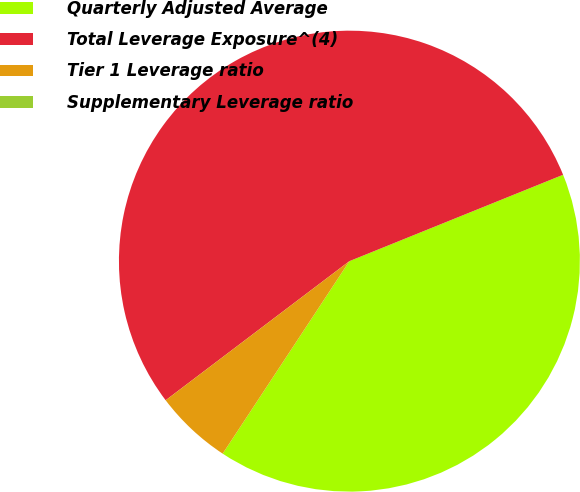Convert chart to OTSL. <chart><loc_0><loc_0><loc_500><loc_500><pie_chart><fcel>Quarterly Adjusted Average<fcel>Total Leverage Exposure^(4)<fcel>Tier 1 Leverage ratio<fcel>Supplementary Leverage ratio<nl><fcel>40.38%<fcel>54.2%<fcel>5.42%<fcel>0.0%<nl></chart> 